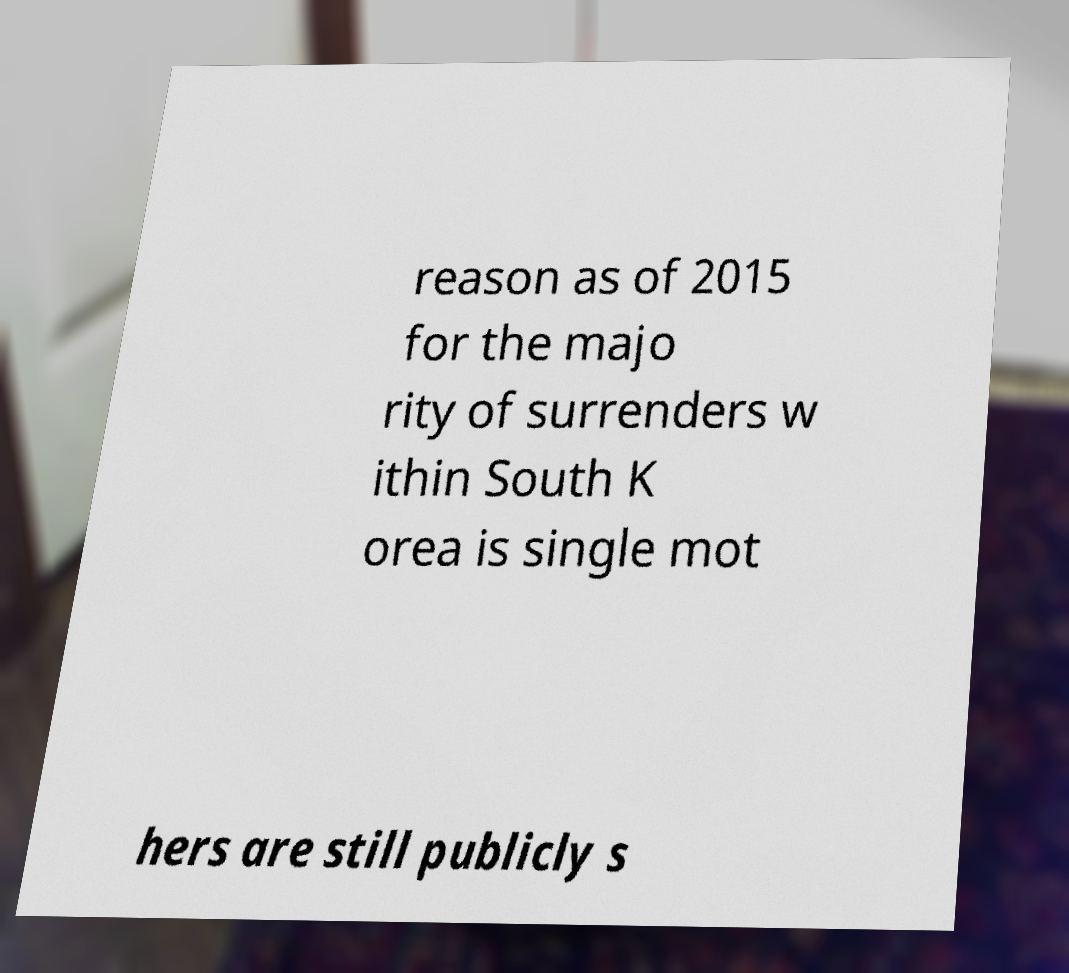Please identify and transcribe the text found in this image. reason as of 2015 for the majo rity of surrenders w ithin South K orea is single mot hers are still publicly s 